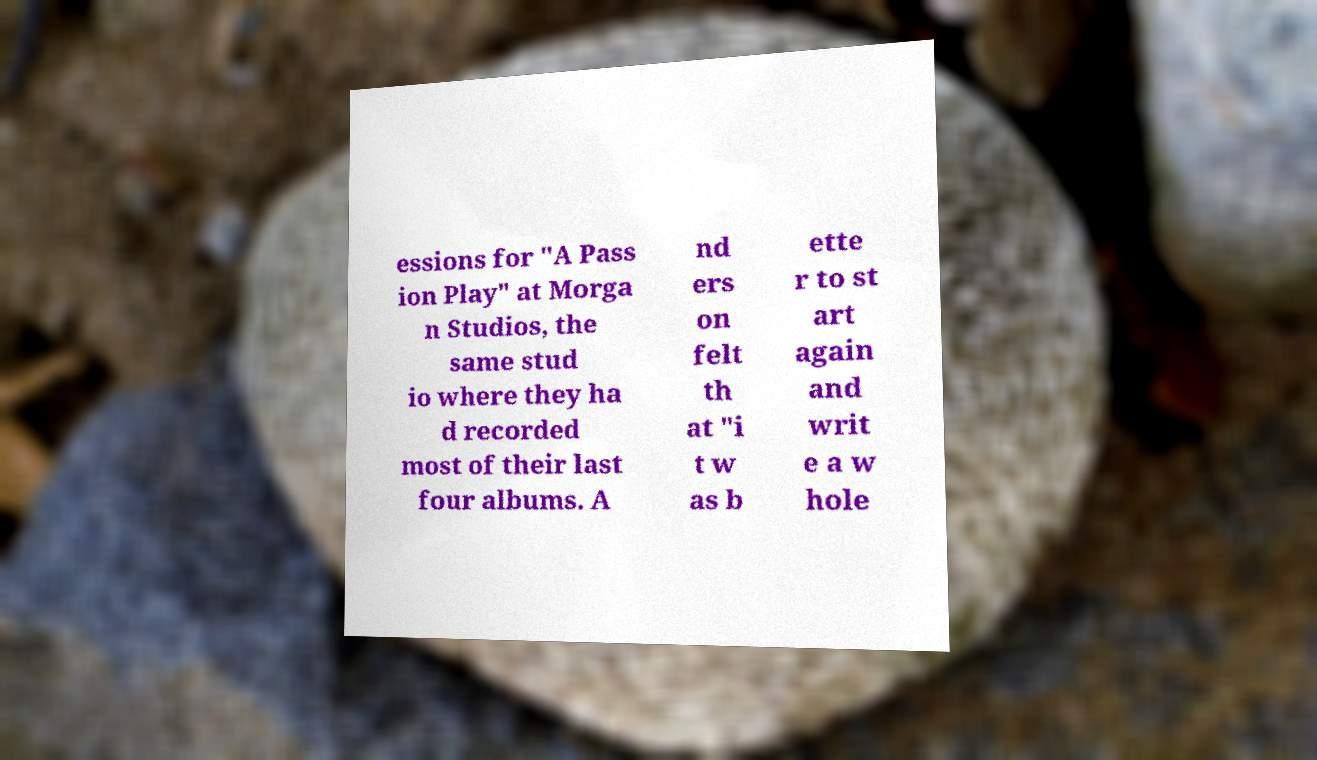Can you accurately transcribe the text from the provided image for me? essions for "A Pass ion Play" at Morga n Studios, the same stud io where they ha d recorded most of their last four albums. A nd ers on felt th at "i t w as b ette r to st art again and writ e a w hole 